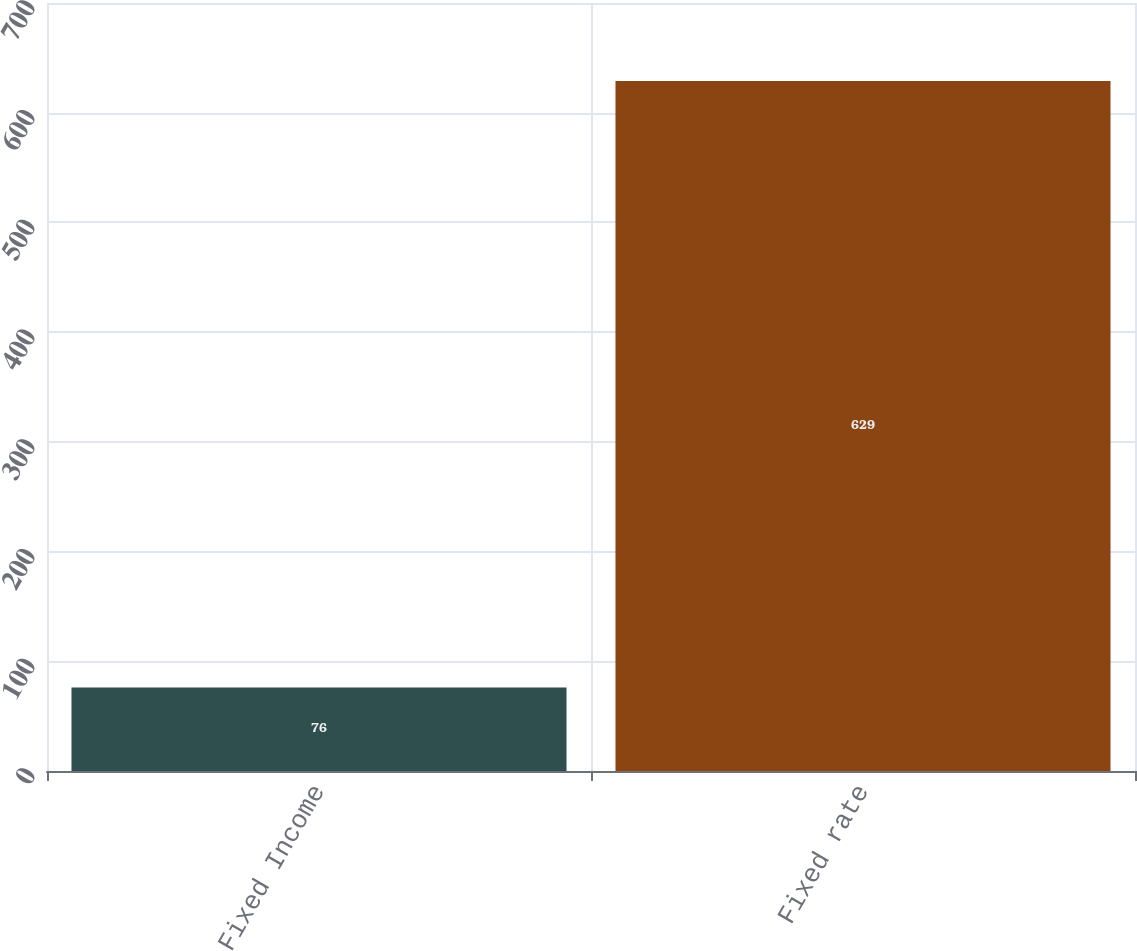Convert chart to OTSL. <chart><loc_0><loc_0><loc_500><loc_500><bar_chart><fcel>Fixed Income<fcel>Fixed rate<nl><fcel>76<fcel>629<nl></chart> 